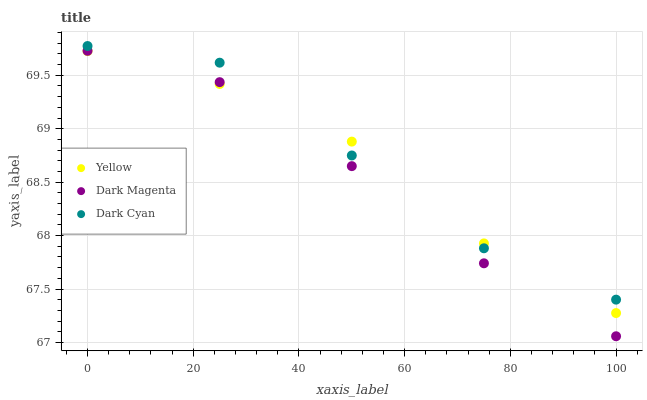Does Dark Magenta have the minimum area under the curve?
Answer yes or no. Yes. Does Dark Cyan have the maximum area under the curve?
Answer yes or no. Yes. Does Yellow have the minimum area under the curve?
Answer yes or no. No. Does Yellow have the maximum area under the curve?
Answer yes or no. No. Is Dark Magenta the smoothest?
Answer yes or no. Yes. Is Dark Cyan the roughest?
Answer yes or no. Yes. Is Yellow the smoothest?
Answer yes or no. No. Is Yellow the roughest?
Answer yes or no. No. Does Dark Magenta have the lowest value?
Answer yes or no. Yes. Does Yellow have the lowest value?
Answer yes or no. No. Does Dark Cyan have the highest value?
Answer yes or no. Yes. Does Dark Magenta have the highest value?
Answer yes or no. No. Is Dark Magenta less than Dark Cyan?
Answer yes or no. Yes. Is Dark Cyan greater than Dark Magenta?
Answer yes or no. Yes. Does Yellow intersect Dark Magenta?
Answer yes or no. Yes. Is Yellow less than Dark Magenta?
Answer yes or no. No. Is Yellow greater than Dark Magenta?
Answer yes or no. No. Does Dark Magenta intersect Dark Cyan?
Answer yes or no. No. 